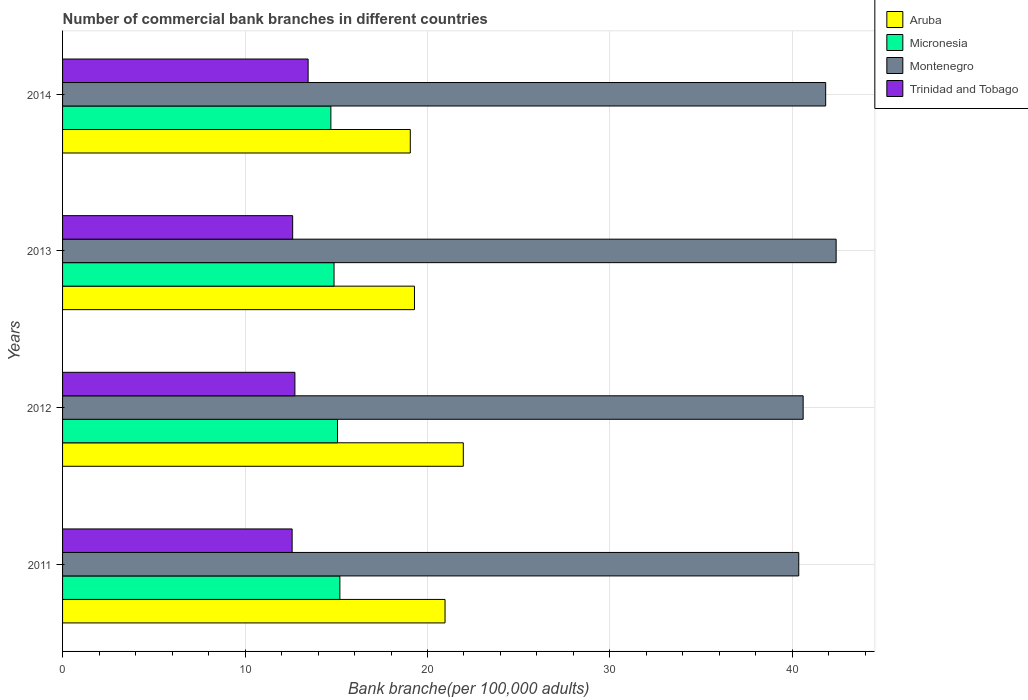How many different coloured bars are there?
Ensure brevity in your answer.  4. How many groups of bars are there?
Your response must be concise. 4. Are the number of bars per tick equal to the number of legend labels?
Your answer should be very brief. Yes. How many bars are there on the 1st tick from the bottom?
Give a very brief answer. 4. What is the label of the 2nd group of bars from the top?
Give a very brief answer. 2013. In how many cases, is the number of bars for a given year not equal to the number of legend labels?
Give a very brief answer. 0. What is the number of commercial bank branches in Trinidad and Tobago in 2012?
Make the answer very short. 12.73. Across all years, what is the maximum number of commercial bank branches in Aruba?
Provide a short and direct response. 21.96. Across all years, what is the minimum number of commercial bank branches in Montenegro?
Give a very brief answer. 40.35. What is the total number of commercial bank branches in Montenegro in the graph?
Offer a terse response. 165.15. What is the difference between the number of commercial bank branches in Micronesia in 2012 and that in 2013?
Offer a terse response. 0.19. What is the difference between the number of commercial bank branches in Aruba in 2014 and the number of commercial bank branches in Montenegro in 2012?
Provide a short and direct response. -21.53. What is the average number of commercial bank branches in Aruba per year?
Give a very brief answer. 20.32. In the year 2013, what is the difference between the number of commercial bank branches in Aruba and number of commercial bank branches in Micronesia?
Ensure brevity in your answer.  4.41. In how many years, is the number of commercial bank branches in Micronesia greater than 28 ?
Provide a short and direct response. 0. What is the ratio of the number of commercial bank branches in Micronesia in 2012 to that in 2014?
Your response must be concise. 1.02. Is the number of commercial bank branches in Aruba in 2011 less than that in 2014?
Your response must be concise. No. Is the difference between the number of commercial bank branches in Aruba in 2013 and 2014 greater than the difference between the number of commercial bank branches in Micronesia in 2013 and 2014?
Give a very brief answer. Yes. What is the difference between the highest and the second highest number of commercial bank branches in Trinidad and Tobago?
Make the answer very short. 0.72. What is the difference between the highest and the lowest number of commercial bank branches in Montenegro?
Your response must be concise. 2.05. In how many years, is the number of commercial bank branches in Aruba greater than the average number of commercial bank branches in Aruba taken over all years?
Offer a very short reply. 2. Is the sum of the number of commercial bank branches in Montenegro in 2013 and 2014 greater than the maximum number of commercial bank branches in Micronesia across all years?
Your answer should be very brief. Yes. What does the 3rd bar from the top in 2013 represents?
Offer a terse response. Micronesia. What does the 3rd bar from the bottom in 2014 represents?
Your answer should be compact. Montenegro. Is it the case that in every year, the sum of the number of commercial bank branches in Montenegro and number of commercial bank branches in Aruba is greater than the number of commercial bank branches in Trinidad and Tobago?
Make the answer very short. Yes. Are all the bars in the graph horizontal?
Offer a terse response. Yes. Does the graph contain any zero values?
Offer a terse response. No. Does the graph contain grids?
Your answer should be very brief. Yes. Where does the legend appear in the graph?
Offer a very short reply. Top right. How are the legend labels stacked?
Provide a succinct answer. Vertical. What is the title of the graph?
Provide a succinct answer. Number of commercial bank branches in different countries. Does "High income: OECD" appear as one of the legend labels in the graph?
Your answer should be very brief. No. What is the label or title of the X-axis?
Your response must be concise. Bank branche(per 100,0 adults). What is the label or title of the Y-axis?
Your response must be concise. Years. What is the Bank branche(per 100,000 adults) in Aruba in 2011?
Provide a succinct answer. 20.96. What is the Bank branche(per 100,000 adults) of Micronesia in 2011?
Ensure brevity in your answer.  15.2. What is the Bank branche(per 100,000 adults) of Montenegro in 2011?
Your answer should be compact. 40.35. What is the Bank branche(per 100,000 adults) of Trinidad and Tobago in 2011?
Offer a very short reply. 12.58. What is the Bank branche(per 100,000 adults) in Aruba in 2012?
Ensure brevity in your answer.  21.96. What is the Bank branche(per 100,000 adults) of Micronesia in 2012?
Make the answer very short. 15.07. What is the Bank branche(per 100,000 adults) of Montenegro in 2012?
Offer a terse response. 40.59. What is the Bank branche(per 100,000 adults) in Trinidad and Tobago in 2012?
Offer a very short reply. 12.73. What is the Bank branche(per 100,000 adults) of Aruba in 2013?
Provide a succinct answer. 19.29. What is the Bank branche(per 100,000 adults) in Micronesia in 2013?
Provide a succinct answer. 14.88. What is the Bank branche(per 100,000 adults) in Montenegro in 2013?
Your answer should be very brief. 42.4. What is the Bank branche(per 100,000 adults) of Trinidad and Tobago in 2013?
Ensure brevity in your answer.  12.61. What is the Bank branche(per 100,000 adults) of Aruba in 2014?
Ensure brevity in your answer.  19.06. What is the Bank branche(per 100,000 adults) of Micronesia in 2014?
Your answer should be very brief. 14.7. What is the Bank branche(per 100,000 adults) of Montenegro in 2014?
Provide a short and direct response. 41.82. What is the Bank branche(per 100,000 adults) of Trinidad and Tobago in 2014?
Your answer should be very brief. 13.46. Across all years, what is the maximum Bank branche(per 100,000 adults) of Aruba?
Provide a succinct answer. 21.96. Across all years, what is the maximum Bank branche(per 100,000 adults) of Micronesia?
Provide a succinct answer. 15.2. Across all years, what is the maximum Bank branche(per 100,000 adults) of Montenegro?
Your response must be concise. 42.4. Across all years, what is the maximum Bank branche(per 100,000 adults) in Trinidad and Tobago?
Offer a very short reply. 13.46. Across all years, what is the minimum Bank branche(per 100,000 adults) of Aruba?
Make the answer very short. 19.06. Across all years, what is the minimum Bank branche(per 100,000 adults) in Micronesia?
Your response must be concise. 14.7. Across all years, what is the minimum Bank branche(per 100,000 adults) in Montenegro?
Your answer should be compact. 40.35. Across all years, what is the minimum Bank branche(per 100,000 adults) in Trinidad and Tobago?
Keep it short and to the point. 12.58. What is the total Bank branche(per 100,000 adults) of Aruba in the graph?
Your response must be concise. 81.27. What is the total Bank branche(per 100,000 adults) in Micronesia in the graph?
Provide a short and direct response. 59.85. What is the total Bank branche(per 100,000 adults) in Montenegro in the graph?
Offer a terse response. 165.15. What is the total Bank branche(per 100,000 adults) of Trinidad and Tobago in the graph?
Offer a very short reply. 51.38. What is the difference between the Bank branche(per 100,000 adults) of Aruba in 2011 and that in 2012?
Ensure brevity in your answer.  -1. What is the difference between the Bank branche(per 100,000 adults) in Micronesia in 2011 and that in 2012?
Provide a succinct answer. 0.13. What is the difference between the Bank branche(per 100,000 adults) of Montenegro in 2011 and that in 2012?
Give a very brief answer. -0.24. What is the difference between the Bank branche(per 100,000 adults) in Trinidad and Tobago in 2011 and that in 2012?
Your answer should be very brief. -0.15. What is the difference between the Bank branche(per 100,000 adults) in Aruba in 2011 and that in 2013?
Your answer should be very brief. 1.68. What is the difference between the Bank branche(per 100,000 adults) in Micronesia in 2011 and that in 2013?
Your answer should be very brief. 0.32. What is the difference between the Bank branche(per 100,000 adults) in Montenegro in 2011 and that in 2013?
Provide a short and direct response. -2.05. What is the difference between the Bank branche(per 100,000 adults) in Trinidad and Tobago in 2011 and that in 2013?
Your answer should be very brief. -0.03. What is the difference between the Bank branche(per 100,000 adults) of Aruba in 2011 and that in 2014?
Ensure brevity in your answer.  1.9. What is the difference between the Bank branche(per 100,000 adults) in Micronesia in 2011 and that in 2014?
Make the answer very short. 0.49. What is the difference between the Bank branche(per 100,000 adults) of Montenegro in 2011 and that in 2014?
Provide a succinct answer. -1.48. What is the difference between the Bank branche(per 100,000 adults) in Trinidad and Tobago in 2011 and that in 2014?
Ensure brevity in your answer.  -0.88. What is the difference between the Bank branche(per 100,000 adults) of Aruba in 2012 and that in 2013?
Give a very brief answer. 2.68. What is the difference between the Bank branche(per 100,000 adults) in Micronesia in 2012 and that in 2013?
Give a very brief answer. 0.19. What is the difference between the Bank branche(per 100,000 adults) of Montenegro in 2012 and that in 2013?
Your answer should be compact. -1.81. What is the difference between the Bank branche(per 100,000 adults) in Trinidad and Tobago in 2012 and that in 2013?
Your answer should be compact. 0.12. What is the difference between the Bank branche(per 100,000 adults) in Aruba in 2012 and that in 2014?
Your response must be concise. 2.9. What is the difference between the Bank branche(per 100,000 adults) of Micronesia in 2012 and that in 2014?
Provide a short and direct response. 0.36. What is the difference between the Bank branche(per 100,000 adults) in Montenegro in 2012 and that in 2014?
Your answer should be compact. -1.23. What is the difference between the Bank branche(per 100,000 adults) of Trinidad and Tobago in 2012 and that in 2014?
Your answer should be very brief. -0.72. What is the difference between the Bank branche(per 100,000 adults) of Aruba in 2013 and that in 2014?
Offer a very short reply. 0.23. What is the difference between the Bank branche(per 100,000 adults) in Micronesia in 2013 and that in 2014?
Make the answer very short. 0.17. What is the difference between the Bank branche(per 100,000 adults) of Montenegro in 2013 and that in 2014?
Offer a very short reply. 0.57. What is the difference between the Bank branche(per 100,000 adults) of Trinidad and Tobago in 2013 and that in 2014?
Ensure brevity in your answer.  -0.85. What is the difference between the Bank branche(per 100,000 adults) of Aruba in 2011 and the Bank branche(per 100,000 adults) of Micronesia in 2012?
Offer a terse response. 5.89. What is the difference between the Bank branche(per 100,000 adults) in Aruba in 2011 and the Bank branche(per 100,000 adults) in Montenegro in 2012?
Your answer should be compact. -19.63. What is the difference between the Bank branche(per 100,000 adults) of Aruba in 2011 and the Bank branche(per 100,000 adults) of Trinidad and Tobago in 2012?
Your response must be concise. 8.23. What is the difference between the Bank branche(per 100,000 adults) of Micronesia in 2011 and the Bank branche(per 100,000 adults) of Montenegro in 2012?
Keep it short and to the point. -25.39. What is the difference between the Bank branche(per 100,000 adults) in Micronesia in 2011 and the Bank branche(per 100,000 adults) in Trinidad and Tobago in 2012?
Provide a short and direct response. 2.46. What is the difference between the Bank branche(per 100,000 adults) of Montenegro in 2011 and the Bank branche(per 100,000 adults) of Trinidad and Tobago in 2012?
Ensure brevity in your answer.  27.61. What is the difference between the Bank branche(per 100,000 adults) of Aruba in 2011 and the Bank branche(per 100,000 adults) of Micronesia in 2013?
Keep it short and to the point. 6.08. What is the difference between the Bank branche(per 100,000 adults) of Aruba in 2011 and the Bank branche(per 100,000 adults) of Montenegro in 2013?
Ensure brevity in your answer.  -21.43. What is the difference between the Bank branche(per 100,000 adults) of Aruba in 2011 and the Bank branche(per 100,000 adults) of Trinidad and Tobago in 2013?
Your answer should be compact. 8.35. What is the difference between the Bank branche(per 100,000 adults) in Micronesia in 2011 and the Bank branche(per 100,000 adults) in Montenegro in 2013?
Provide a short and direct response. -27.2. What is the difference between the Bank branche(per 100,000 adults) of Micronesia in 2011 and the Bank branche(per 100,000 adults) of Trinidad and Tobago in 2013?
Provide a succinct answer. 2.59. What is the difference between the Bank branche(per 100,000 adults) in Montenegro in 2011 and the Bank branche(per 100,000 adults) in Trinidad and Tobago in 2013?
Keep it short and to the point. 27.74. What is the difference between the Bank branche(per 100,000 adults) of Aruba in 2011 and the Bank branche(per 100,000 adults) of Micronesia in 2014?
Make the answer very short. 6.26. What is the difference between the Bank branche(per 100,000 adults) in Aruba in 2011 and the Bank branche(per 100,000 adults) in Montenegro in 2014?
Provide a succinct answer. -20.86. What is the difference between the Bank branche(per 100,000 adults) of Aruba in 2011 and the Bank branche(per 100,000 adults) of Trinidad and Tobago in 2014?
Offer a very short reply. 7.5. What is the difference between the Bank branche(per 100,000 adults) in Micronesia in 2011 and the Bank branche(per 100,000 adults) in Montenegro in 2014?
Your response must be concise. -26.62. What is the difference between the Bank branche(per 100,000 adults) in Micronesia in 2011 and the Bank branche(per 100,000 adults) in Trinidad and Tobago in 2014?
Offer a terse response. 1.74. What is the difference between the Bank branche(per 100,000 adults) in Montenegro in 2011 and the Bank branche(per 100,000 adults) in Trinidad and Tobago in 2014?
Give a very brief answer. 26.89. What is the difference between the Bank branche(per 100,000 adults) of Aruba in 2012 and the Bank branche(per 100,000 adults) of Micronesia in 2013?
Make the answer very short. 7.08. What is the difference between the Bank branche(per 100,000 adults) of Aruba in 2012 and the Bank branche(per 100,000 adults) of Montenegro in 2013?
Your answer should be compact. -20.43. What is the difference between the Bank branche(per 100,000 adults) of Aruba in 2012 and the Bank branche(per 100,000 adults) of Trinidad and Tobago in 2013?
Ensure brevity in your answer.  9.35. What is the difference between the Bank branche(per 100,000 adults) in Micronesia in 2012 and the Bank branche(per 100,000 adults) in Montenegro in 2013?
Keep it short and to the point. -27.33. What is the difference between the Bank branche(per 100,000 adults) in Micronesia in 2012 and the Bank branche(per 100,000 adults) in Trinidad and Tobago in 2013?
Your answer should be very brief. 2.46. What is the difference between the Bank branche(per 100,000 adults) of Montenegro in 2012 and the Bank branche(per 100,000 adults) of Trinidad and Tobago in 2013?
Provide a short and direct response. 27.98. What is the difference between the Bank branche(per 100,000 adults) in Aruba in 2012 and the Bank branche(per 100,000 adults) in Micronesia in 2014?
Offer a very short reply. 7.26. What is the difference between the Bank branche(per 100,000 adults) of Aruba in 2012 and the Bank branche(per 100,000 adults) of Montenegro in 2014?
Provide a short and direct response. -19.86. What is the difference between the Bank branche(per 100,000 adults) in Aruba in 2012 and the Bank branche(per 100,000 adults) in Trinidad and Tobago in 2014?
Make the answer very short. 8.5. What is the difference between the Bank branche(per 100,000 adults) of Micronesia in 2012 and the Bank branche(per 100,000 adults) of Montenegro in 2014?
Keep it short and to the point. -26.75. What is the difference between the Bank branche(per 100,000 adults) of Micronesia in 2012 and the Bank branche(per 100,000 adults) of Trinidad and Tobago in 2014?
Your answer should be compact. 1.61. What is the difference between the Bank branche(per 100,000 adults) in Montenegro in 2012 and the Bank branche(per 100,000 adults) in Trinidad and Tobago in 2014?
Your answer should be very brief. 27.13. What is the difference between the Bank branche(per 100,000 adults) in Aruba in 2013 and the Bank branche(per 100,000 adults) in Micronesia in 2014?
Make the answer very short. 4.58. What is the difference between the Bank branche(per 100,000 adults) of Aruba in 2013 and the Bank branche(per 100,000 adults) of Montenegro in 2014?
Your answer should be very brief. -22.54. What is the difference between the Bank branche(per 100,000 adults) in Aruba in 2013 and the Bank branche(per 100,000 adults) in Trinidad and Tobago in 2014?
Offer a very short reply. 5.83. What is the difference between the Bank branche(per 100,000 adults) of Micronesia in 2013 and the Bank branche(per 100,000 adults) of Montenegro in 2014?
Give a very brief answer. -26.94. What is the difference between the Bank branche(per 100,000 adults) of Micronesia in 2013 and the Bank branche(per 100,000 adults) of Trinidad and Tobago in 2014?
Provide a succinct answer. 1.42. What is the difference between the Bank branche(per 100,000 adults) in Montenegro in 2013 and the Bank branche(per 100,000 adults) in Trinidad and Tobago in 2014?
Keep it short and to the point. 28.94. What is the average Bank branche(per 100,000 adults) in Aruba per year?
Offer a terse response. 20.32. What is the average Bank branche(per 100,000 adults) of Micronesia per year?
Your answer should be compact. 14.96. What is the average Bank branche(per 100,000 adults) of Montenegro per year?
Ensure brevity in your answer.  41.29. What is the average Bank branche(per 100,000 adults) of Trinidad and Tobago per year?
Your response must be concise. 12.85. In the year 2011, what is the difference between the Bank branche(per 100,000 adults) in Aruba and Bank branche(per 100,000 adults) in Micronesia?
Your response must be concise. 5.76. In the year 2011, what is the difference between the Bank branche(per 100,000 adults) of Aruba and Bank branche(per 100,000 adults) of Montenegro?
Make the answer very short. -19.39. In the year 2011, what is the difference between the Bank branche(per 100,000 adults) in Aruba and Bank branche(per 100,000 adults) in Trinidad and Tobago?
Ensure brevity in your answer.  8.38. In the year 2011, what is the difference between the Bank branche(per 100,000 adults) of Micronesia and Bank branche(per 100,000 adults) of Montenegro?
Offer a terse response. -25.15. In the year 2011, what is the difference between the Bank branche(per 100,000 adults) of Micronesia and Bank branche(per 100,000 adults) of Trinidad and Tobago?
Your response must be concise. 2.62. In the year 2011, what is the difference between the Bank branche(per 100,000 adults) in Montenegro and Bank branche(per 100,000 adults) in Trinidad and Tobago?
Your answer should be very brief. 27.76. In the year 2012, what is the difference between the Bank branche(per 100,000 adults) of Aruba and Bank branche(per 100,000 adults) of Micronesia?
Provide a short and direct response. 6.89. In the year 2012, what is the difference between the Bank branche(per 100,000 adults) of Aruba and Bank branche(per 100,000 adults) of Montenegro?
Give a very brief answer. -18.63. In the year 2012, what is the difference between the Bank branche(per 100,000 adults) in Aruba and Bank branche(per 100,000 adults) in Trinidad and Tobago?
Your answer should be compact. 9.23. In the year 2012, what is the difference between the Bank branche(per 100,000 adults) in Micronesia and Bank branche(per 100,000 adults) in Montenegro?
Your answer should be very brief. -25.52. In the year 2012, what is the difference between the Bank branche(per 100,000 adults) in Micronesia and Bank branche(per 100,000 adults) in Trinidad and Tobago?
Offer a very short reply. 2.33. In the year 2012, what is the difference between the Bank branche(per 100,000 adults) of Montenegro and Bank branche(per 100,000 adults) of Trinidad and Tobago?
Provide a short and direct response. 27.85. In the year 2013, what is the difference between the Bank branche(per 100,000 adults) of Aruba and Bank branche(per 100,000 adults) of Micronesia?
Provide a short and direct response. 4.41. In the year 2013, what is the difference between the Bank branche(per 100,000 adults) of Aruba and Bank branche(per 100,000 adults) of Montenegro?
Ensure brevity in your answer.  -23.11. In the year 2013, what is the difference between the Bank branche(per 100,000 adults) of Aruba and Bank branche(per 100,000 adults) of Trinidad and Tobago?
Ensure brevity in your answer.  6.68. In the year 2013, what is the difference between the Bank branche(per 100,000 adults) in Micronesia and Bank branche(per 100,000 adults) in Montenegro?
Keep it short and to the point. -27.52. In the year 2013, what is the difference between the Bank branche(per 100,000 adults) in Micronesia and Bank branche(per 100,000 adults) in Trinidad and Tobago?
Your answer should be compact. 2.27. In the year 2013, what is the difference between the Bank branche(per 100,000 adults) of Montenegro and Bank branche(per 100,000 adults) of Trinidad and Tobago?
Offer a terse response. 29.79. In the year 2014, what is the difference between the Bank branche(per 100,000 adults) of Aruba and Bank branche(per 100,000 adults) of Micronesia?
Ensure brevity in your answer.  4.35. In the year 2014, what is the difference between the Bank branche(per 100,000 adults) of Aruba and Bank branche(per 100,000 adults) of Montenegro?
Ensure brevity in your answer.  -22.76. In the year 2014, what is the difference between the Bank branche(per 100,000 adults) of Aruba and Bank branche(per 100,000 adults) of Trinidad and Tobago?
Make the answer very short. 5.6. In the year 2014, what is the difference between the Bank branche(per 100,000 adults) of Micronesia and Bank branche(per 100,000 adults) of Montenegro?
Ensure brevity in your answer.  -27.12. In the year 2014, what is the difference between the Bank branche(per 100,000 adults) in Micronesia and Bank branche(per 100,000 adults) in Trinidad and Tobago?
Give a very brief answer. 1.25. In the year 2014, what is the difference between the Bank branche(per 100,000 adults) in Montenegro and Bank branche(per 100,000 adults) in Trinidad and Tobago?
Provide a short and direct response. 28.36. What is the ratio of the Bank branche(per 100,000 adults) of Aruba in 2011 to that in 2012?
Your answer should be compact. 0.95. What is the ratio of the Bank branche(per 100,000 adults) of Micronesia in 2011 to that in 2012?
Your answer should be compact. 1.01. What is the ratio of the Bank branche(per 100,000 adults) of Montenegro in 2011 to that in 2012?
Your answer should be very brief. 0.99. What is the ratio of the Bank branche(per 100,000 adults) of Trinidad and Tobago in 2011 to that in 2012?
Make the answer very short. 0.99. What is the ratio of the Bank branche(per 100,000 adults) in Aruba in 2011 to that in 2013?
Your answer should be very brief. 1.09. What is the ratio of the Bank branche(per 100,000 adults) of Micronesia in 2011 to that in 2013?
Your answer should be compact. 1.02. What is the ratio of the Bank branche(per 100,000 adults) of Montenegro in 2011 to that in 2013?
Offer a very short reply. 0.95. What is the ratio of the Bank branche(per 100,000 adults) of Aruba in 2011 to that in 2014?
Offer a terse response. 1.1. What is the ratio of the Bank branche(per 100,000 adults) of Micronesia in 2011 to that in 2014?
Make the answer very short. 1.03. What is the ratio of the Bank branche(per 100,000 adults) of Montenegro in 2011 to that in 2014?
Your answer should be compact. 0.96. What is the ratio of the Bank branche(per 100,000 adults) of Trinidad and Tobago in 2011 to that in 2014?
Your response must be concise. 0.93. What is the ratio of the Bank branche(per 100,000 adults) in Aruba in 2012 to that in 2013?
Provide a succinct answer. 1.14. What is the ratio of the Bank branche(per 100,000 adults) in Micronesia in 2012 to that in 2013?
Ensure brevity in your answer.  1.01. What is the ratio of the Bank branche(per 100,000 adults) in Montenegro in 2012 to that in 2013?
Offer a terse response. 0.96. What is the ratio of the Bank branche(per 100,000 adults) of Trinidad and Tobago in 2012 to that in 2013?
Your answer should be very brief. 1.01. What is the ratio of the Bank branche(per 100,000 adults) of Aruba in 2012 to that in 2014?
Offer a very short reply. 1.15. What is the ratio of the Bank branche(per 100,000 adults) in Micronesia in 2012 to that in 2014?
Offer a very short reply. 1.02. What is the ratio of the Bank branche(per 100,000 adults) in Montenegro in 2012 to that in 2014?
Provide a short and direct response. 0.97. What is the ratio of the Bank branche(per 100,000 adults) of Trinidad and Tobago in 2012 to that in 2014?
Provide a short and direct response. 0.95. What is the ratio of the Bank branche(per 100,000 adults) in Micronesia in 2013 to that in 2014?
Your response must be concise. 1.01. What is the ratio of the Bank branche(per 100,000 adults) in Montenegro in 2013 to that in 2014?
Ensure brevity in your answer.  1.01. What is the ratio of the Bank branche(per 100,000 adults) of Trinidad and Tobago in 2013 to that in 2014?
Provide a short and direct response. 0.94. What is the difference between the highest and the second highest Bank branche(per 100,000 adults) in Aruba?
Give a very brief answer. 1. What is the difference between the highest and the second highest Bank branche(per 100,000 adults) in Micronesia?
Offer a very short reply. 0.13. What is the difference between the highest and the second highest Bank branche(per 100,000 adults) in Montenegro?
Offer a very short reply. 0.57. What is the difference between the highest and the second highest Bank branche(per 100,000 adults) of Trinidad and Tobago?
Provide a short and direct response. 0.72. What is the difference between the highest and the lowest Bank branche(per 100,000 adults) of Aruba?
Your answer should be compact. 2.9. What is the difference between the highest and the lowest Bank branche(per 100,000 adults) in Micronesia?
Provide a short and direct response. 0.49. What is the difference between the highest and the lowest Bank branche(per 100,000 adults) in Montenegro?
Your answer should be very brief. 2.05. What is the difference between the highest and the lowest Bank branche(per 100,000 adults) of Trinidad and Tobago?
Give a very brief answer. 0.88. 